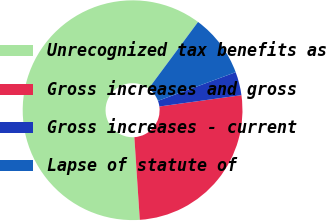Convert chart to OTSL. <chart><loc_0><loc_0><loc_500><loc_500><pie_chart><fcel>Unrecognized tax benefits as<fcel>Gross increases and gross<fcel>Gross increases - current<fcel>Lapse of statute of<nl><fcel>61.2%<fcel>26.14%<fcel>3.44%<fcel>9.22%<nl></chart> 